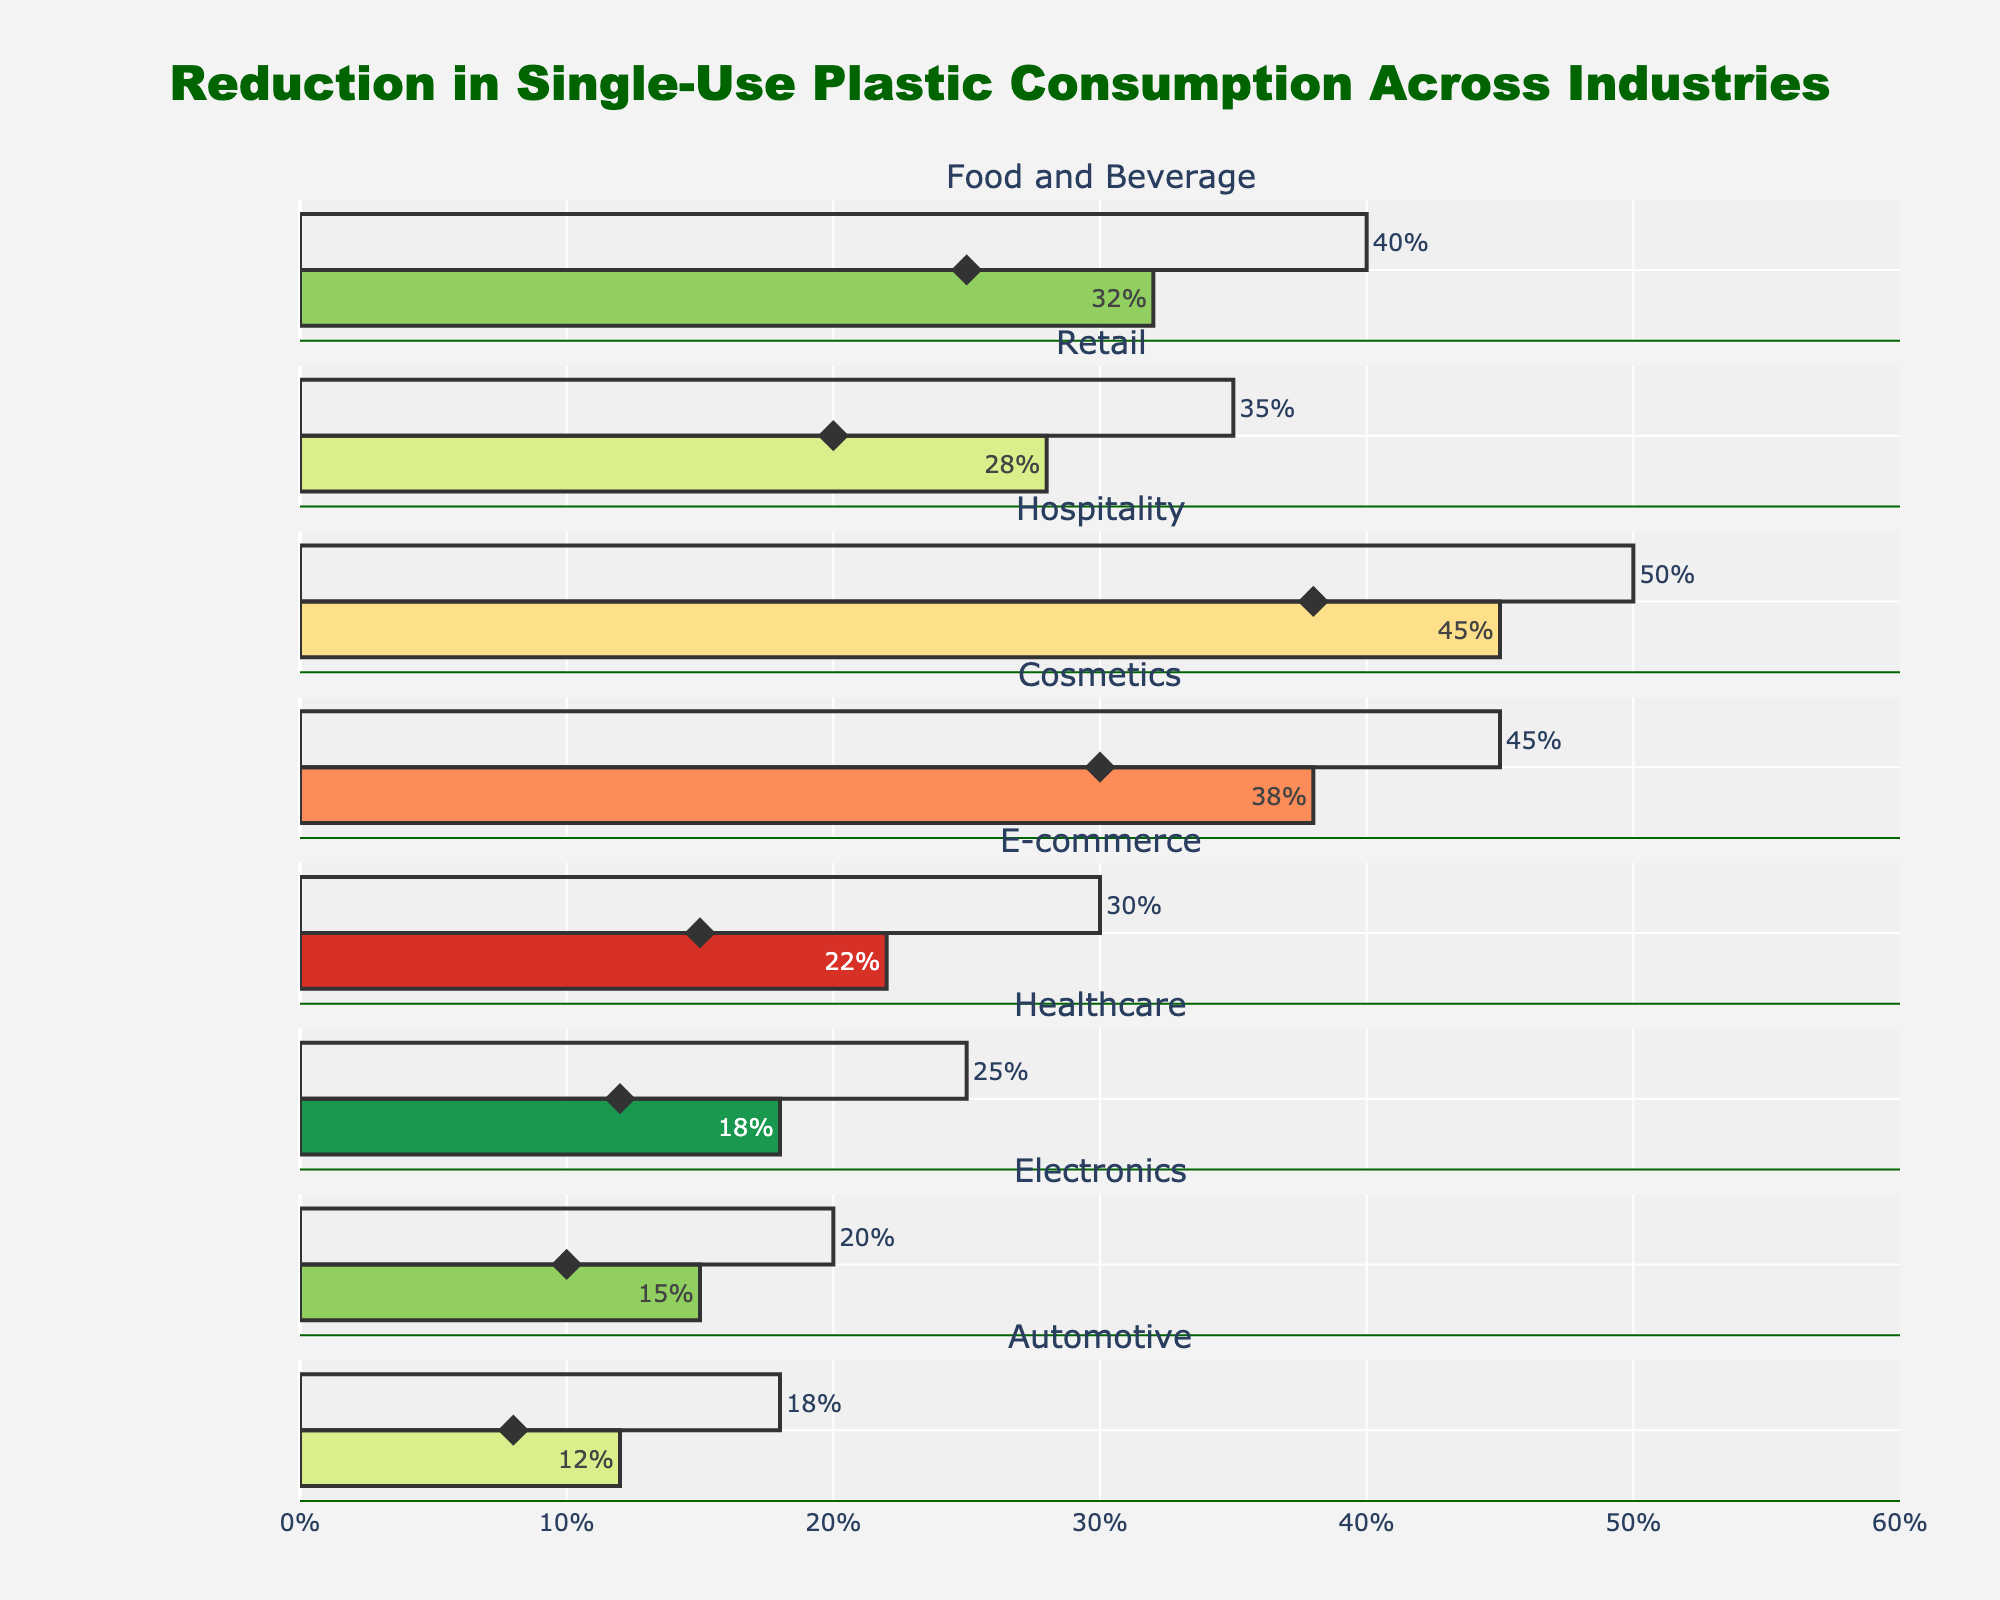Which industry has the highest actual reduction in single-use plastic consumption? The industry with the highest actual reduction will be the one with the longest bar for actual reduction in the figure. The Hospitality industry has an actual reduction of 45%, which is the highest.
Answer: Hospitality What is the target reduction percentage of the Automotive industry? The target reduction percentage can be found by looking at the end position of the bar for the target reduction in the Automotive industry section. It is labeled as 18%.
Answer: 18% Compare the actual reduction percentage of the Retail and E-commerce industries. Which one is greater? By comparing the lengths of the bars representing the actual reduction for both industries, Retail shows 28% and E-commerce shows 22%. Thus, Retail has a greater actual reduction.
Answer: Retail How did the Food and Beverage industry perform this year compared to the previous year in terms of reduction percentage? The actual reduction for this year is 32%, and the previous year's reduction is marked with a diamond symbol showing 25%. The current year's reduction is higher by 7%.
Answer: 32% this year, 25% previous year What is the difference between the target reduction and the actual reduction of the Healthcare industry? The target reduction is labeled as 25%, and the actual reduction is shown as 18%. The difference is calculated as 25% - 18% = 7%.
Answer: 7% Which industry has the smallest difference between its actual and target reduction percentages? The difference is calculated by subtracting the actual reduction from the target reduction for each industry. Automotive has a target of 18% and actual of 12%, resulting in a difference of 6%, which is the smallest.
Answer: Automotive What is the overall range of actual reduction percentages across all industries? The minimum actual reduction percentage is 12% in the Automotive industry, and the maximum is 45% in the Hospitality industry. The range is calculated as 45% - 12% = 33%.
Answer: 33% How many industries have an actual reduction percentage greater than their previous year's reduction percentage? By comparing the actual and previous year reduction percentages for each industry, we see that all industries show an increase. Hence, there are 8 industries with an actual reduction greater than their previous year's reduction.
Answer: 8 